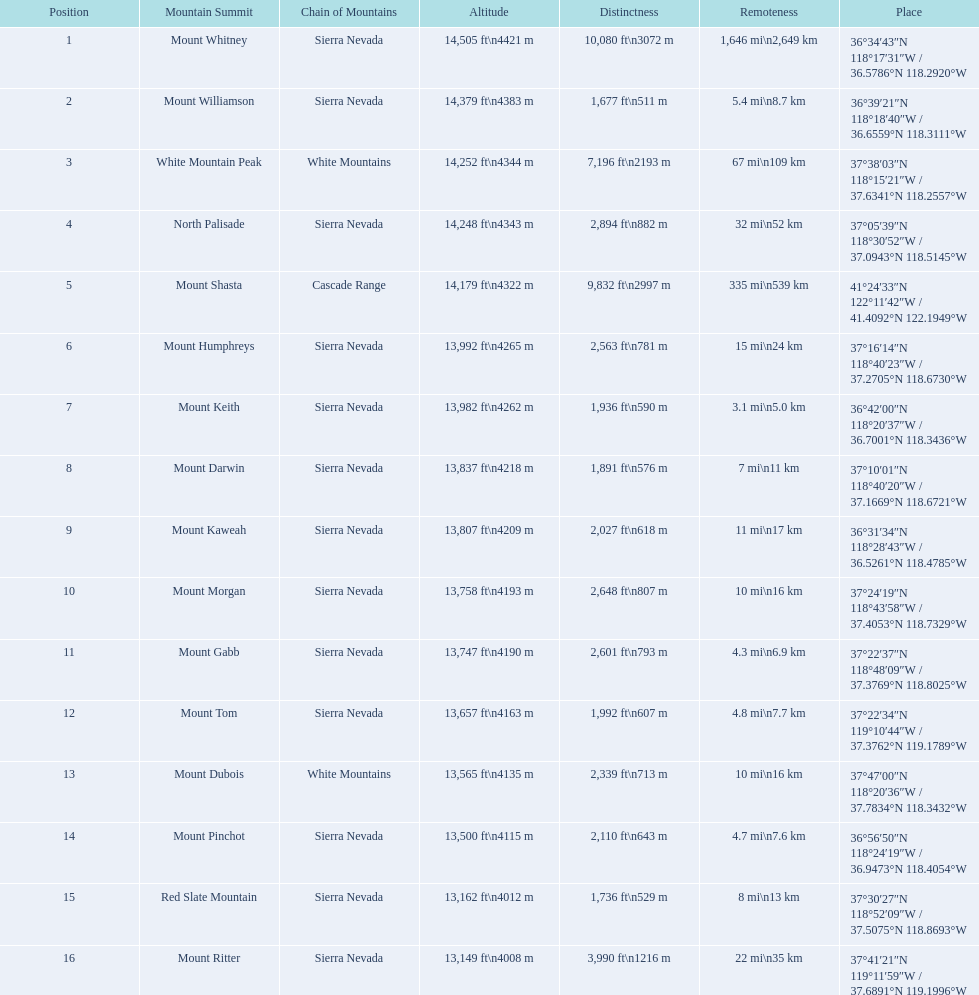How much taller is the mountain peak of mount williamson than that of mount keith? 397 ft. Can you give me this table as a dict? {'header': ['Position', 'Mountain Summit', 'Chain of Mountains', 'Altitude', 'Distinctness', 'Remoteness', 'Place'], 'rows': [['1', 'Mount Whitney', 'Sierra Nevada', '14,505\xa0ft\\n4421\xa0m', '10,080\xa0ft\\n3072\xa0m', '1,646\xa0mi\\n2,649\xa0km', '36°34′43″N 118°17′31″W\ufeff / \ufeff36.5786°N 118.2920°W'], ['2', 'Mount Williamson', 'Sierra Nevada', '14,379\xa0ft\\n4383\xa0m', '1,677\xa0ft\\n511\xa0m', '5.4\xa0mi\\n8.7\xa0km', '36°39′21″N 118°18′40″W\ufeff / \ufeff36.6559°N 118.3111°W'], ['3', 'White Mountain Peak', 'White Mountains', '14,252\xa0ft\\n4344\xa0m', '7,196\xa0ft\\n2193\xa0m', '67\xa0mi\\n109\xa0km', '37°38′03″N 118°15′21″W\ufeff / \ufeff37.6341°N 118.2557°W'], ['4', 'North Palisade', 'Sierra Nevada', '14,248\xa0ft\\n4343\xa0m', '2,894\xa0ft\\n882\xa0m', '32\xa0mi\\n52\xa0km', '37°05′39″N 118°30′52″W\ufeff / \ufeff37.0943°N 118.5145°W'], ['5', 'Mount Shasta', 'Cascade Range', '14,179\xa0ft\\n4322\xa0m', '9,832\xa0ft\\n2997\xa0m', '335\xa0mi\\n539\xa0km', '41°24′33″N 122°11′42″W\ufeff / \ufeff41.4092°N 122.1949°W'], ['6', 'Mount Humphreys', 'Sierra Nevada', '13,992\xa0ft\\n4265\xa0m', '2,563\xa0ft\\n781\xa0m', '15\xa0mi\\n24\xa0km', '37°16′14″N 118°40′23″W\ufeff / \ufeff37.2705°N 118.6730°W'], ['7', 'Mount Keith', 'Sierra Nevada', '13,982\xa0ft\\n4262\xa0m', '1,936\xa0ft\\n590\xa0m', '3.1\xa0mi\\n5.0\xa0km', '36°42′00″N 118°20′37″W\ufeff / \ufeff36.7001°N 118.3436°W'], ['8', 'Mount Darwin', 'Sierra Nevada', '13,837\xa0ft\\n4218\xa0m', '1,891\xa0ft\\n576\xa0m', '7\xa0mi\\n11\xa0km', '37°10′01″N 118°40′20″W\ufeff / \ufeff37.1669°N 118.6721°W'], ['9', 'Mount Kaweah', 'Sierra Nevada', '13,807\xa0ft\\n4209\xa0m', '2,027\xa0ft\\n618\xa0m', '11\xa0mi\\n17\xa0km', '36°31′34″N 118°28′43″W\ufeff / \ufeff36.5261°N 118.4785°W'], ['10', 'Mount Morgan', 'Sierra Nevada', '13,758\xa0ft\\n4193\xa0m', '2,648\xa0ft\\n807\xa0m', '10\xa0mi\\n16\xa0km', '37°24′19″N 118°43′58″W\ufeff / \ufeff37.4053°N 118.7329°W'], ['11', 'Mount Gabb', 'Sierra Nevada', '13,747\xa0ft\\n4190\xa0m', '2,601\xa0ft\\n793\xa0m', '4.3\xa0mi\\n6.9\xa0km', '37°22′37″N 118°48′09″W\ufeff / \ufeff37.3769°N 118.8025°W'], ['12', 'Mount Tom', 'Sierra Nevada', '13,657\xa0ft\\n4163\xa0m', '1,992\xa0ft\\n607\xa0m', '4.8\xa0mi\\n7.7\xa0km', '37°22′34″N 119°10′44″W\ufeff / \ufeff37.3762°N 119.1789°W'], ['13', 'Mount Dubois', 'White Mountains', '13,565\xa0ft\\n4135\xa0m', '2,339\xa0ft\\n713\xa0m', '10\xa0mi\\n16\xa0km', '37°47′00″N 118°20′36″W\ufeff / \ufeff37.7834°N 118.3432°W'], ['14', 'Mount Pinchot', 'Sierra Nevada', '13,500\xa0ft\\n4115\xa0m', '2,110\xa0ft\\n643\xa0m', '4.7\xa0mi\\n7.6\xa0km', '36°56′50″N 118°24′19″W\ufeff / \ufeff36.9473°N 118.4054°W'], ['15', 'Red Slate Mountain', 'Sierra Nevada', '13,162\xa0ft\\n4012\xa0m', '1,736\xa0ft\\n529\xa0m', '8\xa0mi\\n13\xa0km', '37°30′27″N 118°52′09″W\ufeff / \ufeff37.5075°N 118.8693°W'], ['16', 'Mount Ritter', 'Sierra Nevada', '13,149\xa0ft\\n4008\xa0m', '3,990\xa0ft\\n1216\xa0m', '22\xa0mi\\n35\xa0km', '37°41′21″N 119°11′59″W\ufeff / \ufeff37.6891°N 119.1996°W']]} 